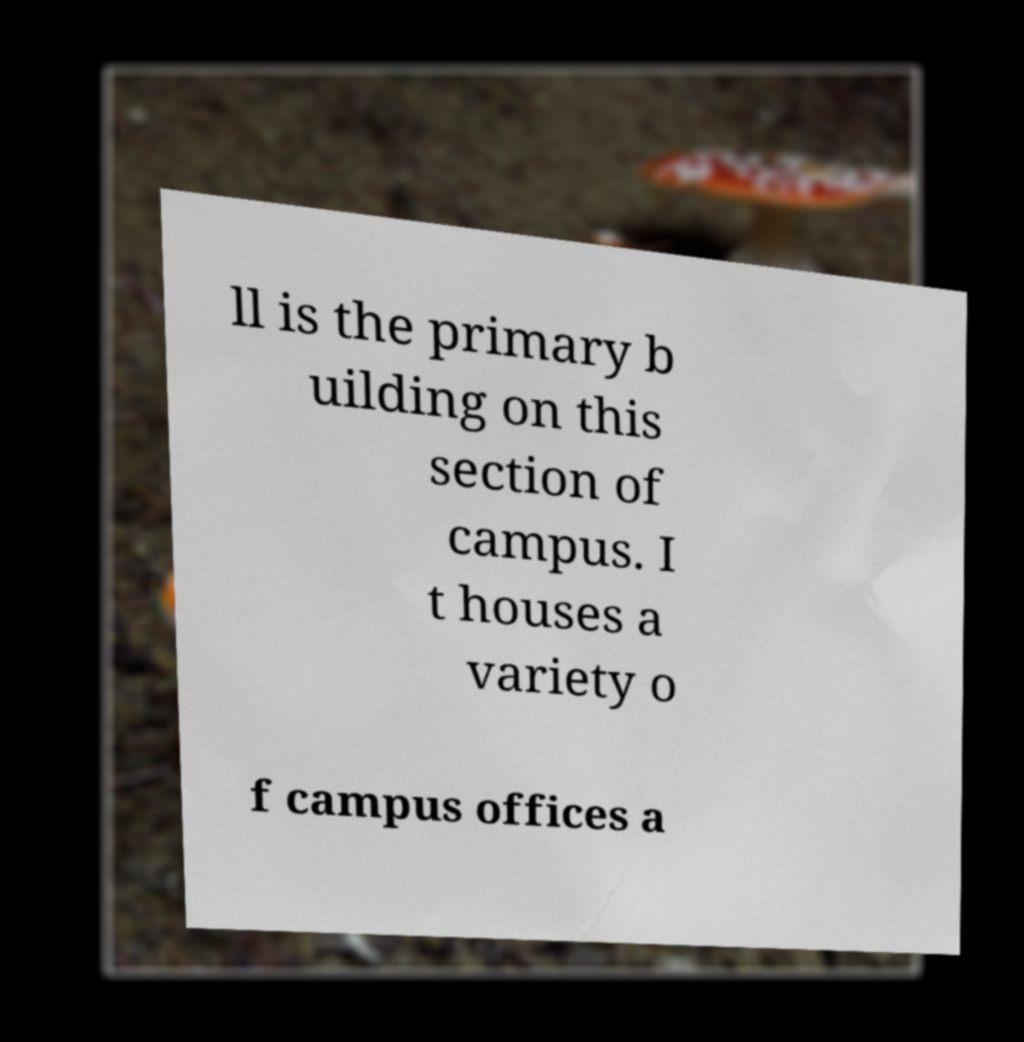For documentation purposes, I need the text within this image transcribed. Could you provide that? ll is the primary b uilding on this section of campus. I t houses a variety o f campus offices a 